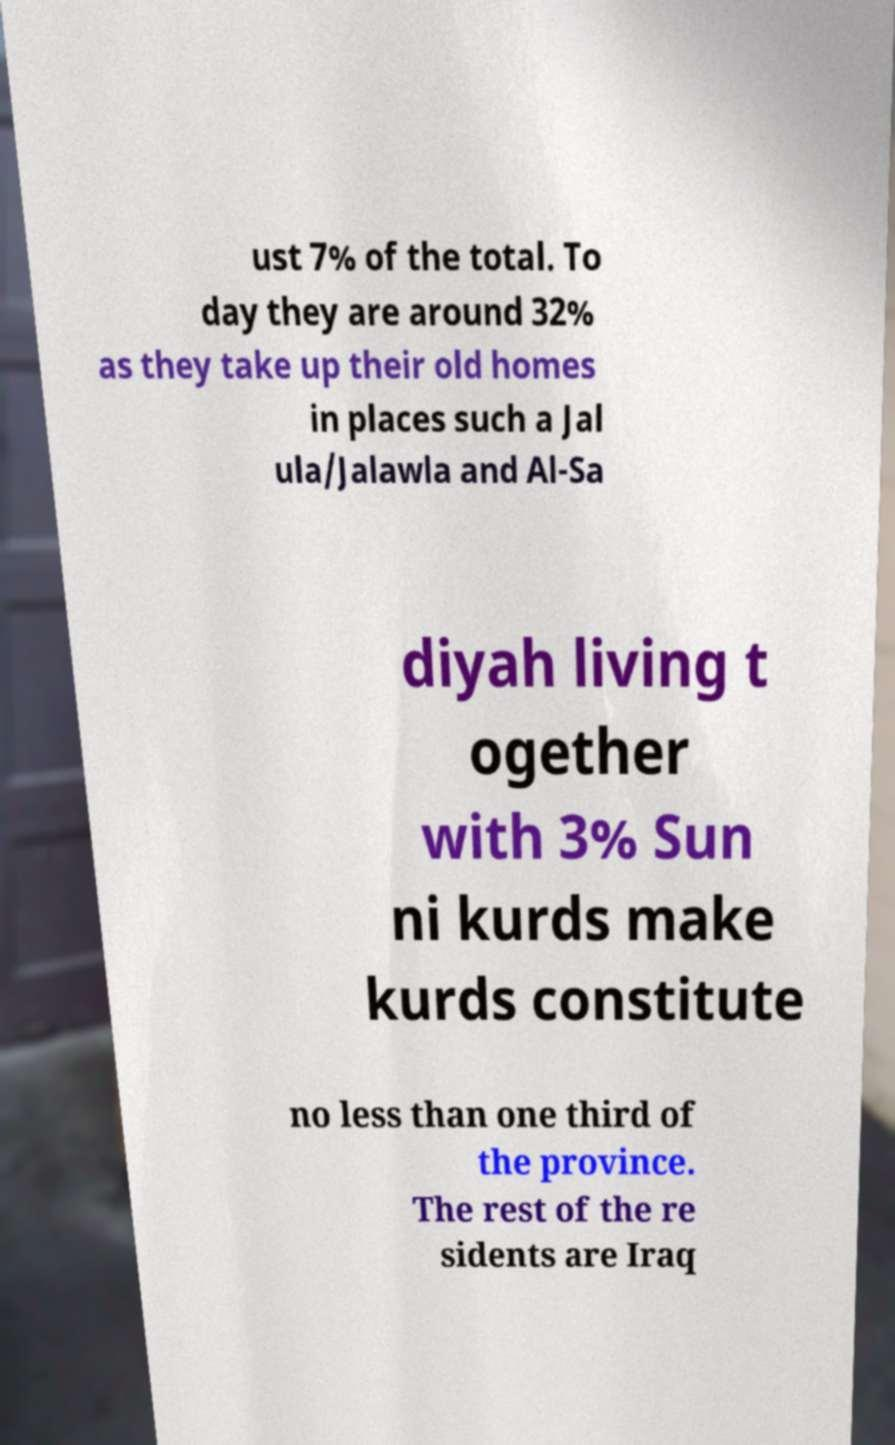Could you assist in decoding the text presented in this image and type it out clearly? ust 7% of the total. To day they are around 32% as they take up their old homes in places such a Jal ula/Jalawla and Al-Sa diyah living t ogether with 3% Sun ni kurds make kurds constitute no less than one third of the province. The rest of the re sidents are Iraq 